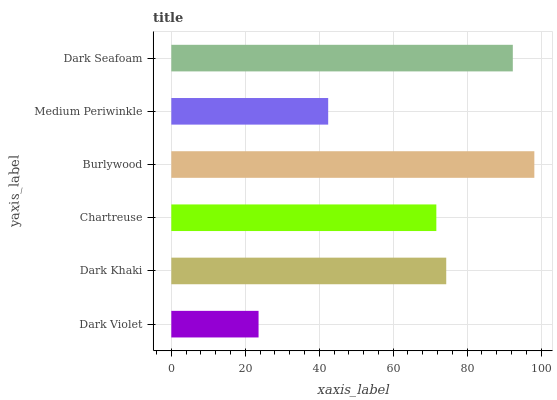Is Dark Violet the minimum?
Answer yes or no. Yes. Is Burlywood the maximum?
Answer yes or no. Yes. Is Dark Khaki the minimum?
Answer yes or no. No. Is Dark Khaki the maximum?
Answer yes or no. No. Is Dark Khaki greater than Dark Violet?
Answer yes or no. Yes. Is Dark Violet less than Dark Khaki?
Answer yes or no. Yes. Is Dark Violet greater than Dark Khaki?
Answer yes or no. No. Is Dark Khaki less than Dark Violet?
Answer yes or no. No. Is Dark Khaki the high median?
Answer yes or no. Yes. Is Chartreuse the low median?
Answer yes or no. Yes. Is Burlywood the high median?
Answer yes or no. No. Is Medium Periwinkle the low median?
Answer yes or no. No. 